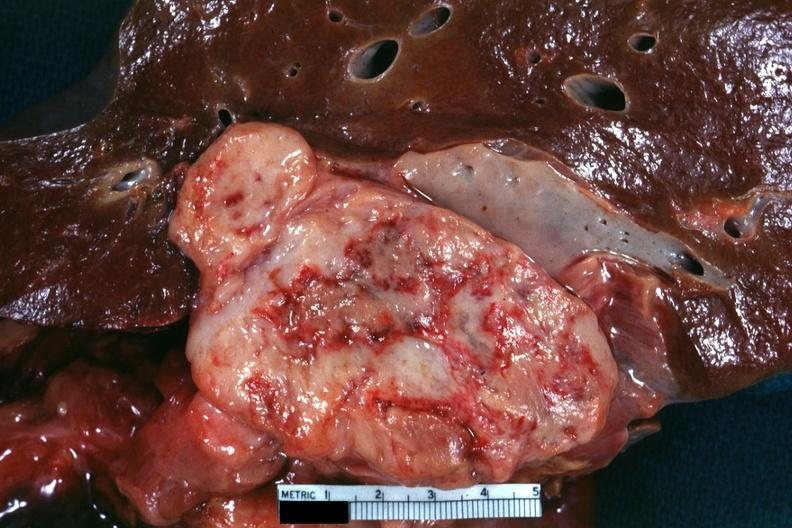s abdomen present?
Answer the question using a single word or phrase. Yes 